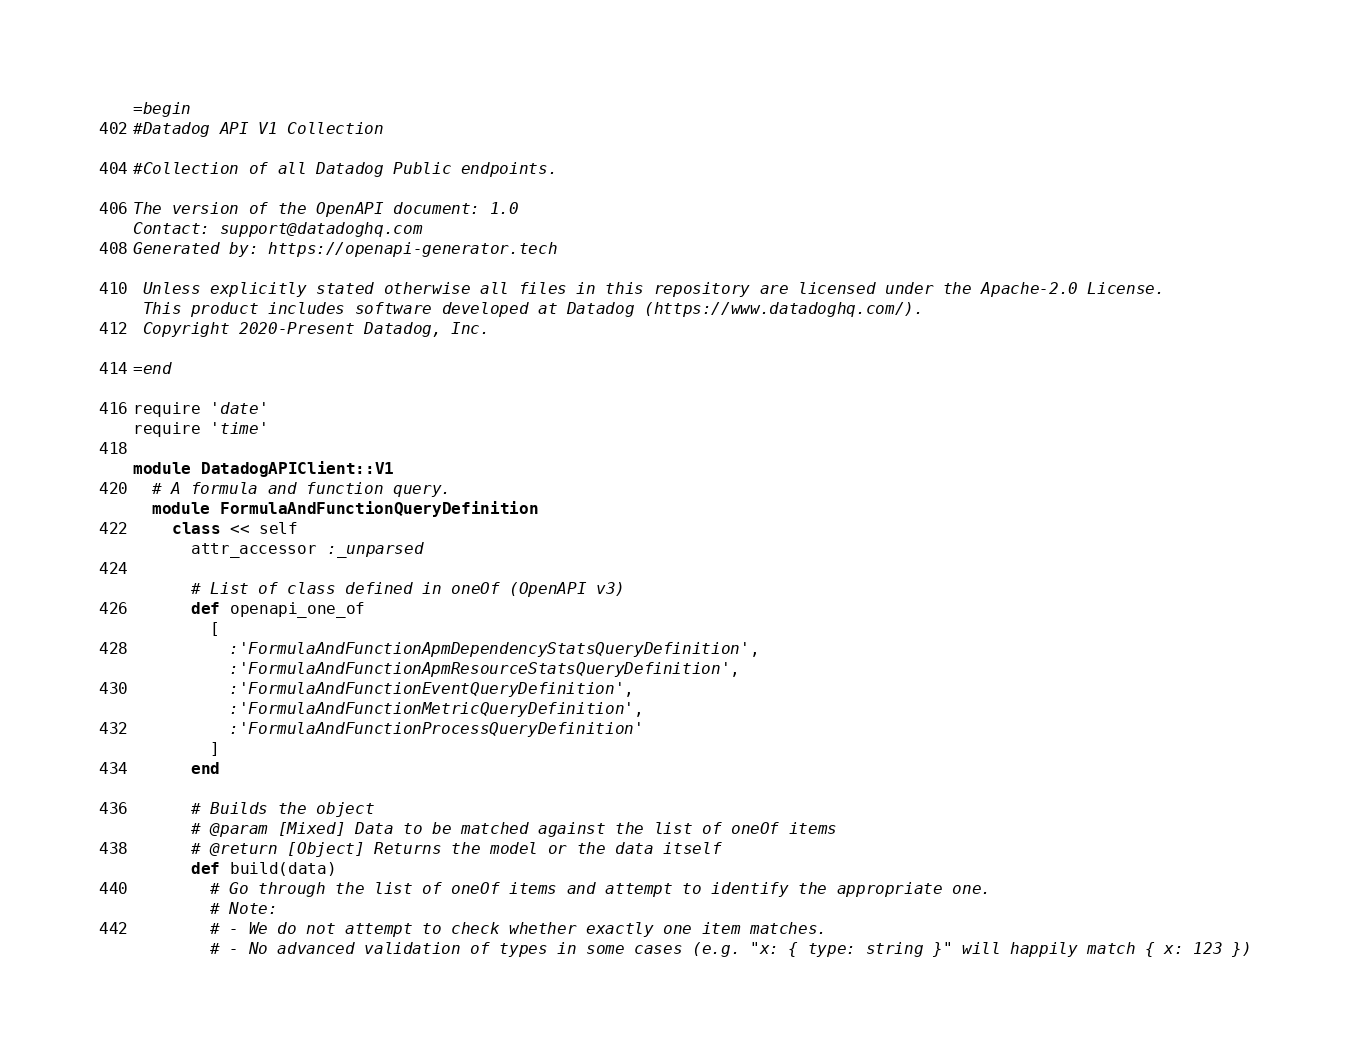<code> <loc_0><loc_0><loc_500><loc_500><_Ruby_>=begin
#Datadog API V1 Collection

#Collection of all Datadog Public endpoints.

The version of the OpenAPI document: 1.0
Contact: support@datadoghq.com
Generated by: https://openapi-generator.tech

 Unless explicitly stated otherwise all files in this repository are licensed under the Apache-2.0 License.
 This product includes software developed at Datadog (https://www.datadoghq.com/).
 Copyright 2020-Present Datadog, Inc.

=end

require 'date'
require 'time'

module DatadogAPIClient::V1
  # A formula and function query.
  module FormulaAndFunctionQueryDefinition
    class << self
      attr_accessor :_unparsed

      # List of class defined in oneOf (OpenAPI v3)
      def openapi_one_of
        [
          :'FormulaAndFunctionApmDependencyStatsQueryDefinition',
          :'FormulaAndFunctionApmResourceStatsQueryDefinition',
          :'FormulaAndFunctionEventQueryDefinition',
          :'FormulaAndFunctionMetricQueryDefinition',
          :'FormulaAndFunctionProcessQueryDefinition'
        ]
      end

      # Builds the object
      # @param [Mixed] Data to be matched against the list of oneOf items
      # @return [Object] Returns the model or the data itself
      def build(data)
        # Go through the list of oneOf items and attempt to identify the appropriate one.
        # Note:
        # - We do not attempt to check whether exactly one item matches.
        # - No advanced validation of types in some cases (e.g. "x: { type: string }" will happily match { x: 123 })</code> 